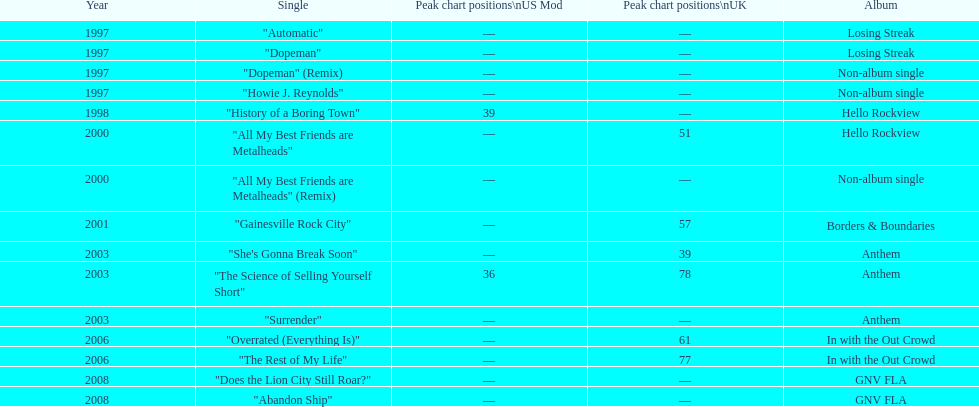What was the earliest single to attain a chart spot? "History of a Boring Town". 